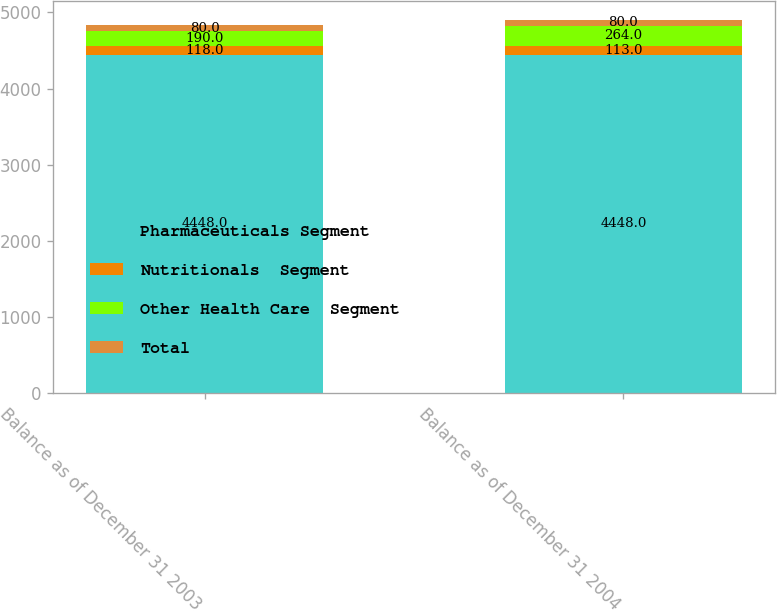Convert chart. <chart><loc_0><loc_0><loc_500><loc_500><stacked_bar_chart><ecel><fcel>Balance as of December 31 2003<fcel>Balance as of December 31 2004<nl><fcel>Pharmaceuticals Segment<fcel>4448<fcel>4448<nl><fcel>Nutritionals  Segment<fcel>118<fcel>113<nl><fcel>Other Health Care  Segment<fcel>190<fcel>264<nl><fcel>Total<fcel>80<fcel>80<nl></chart> 